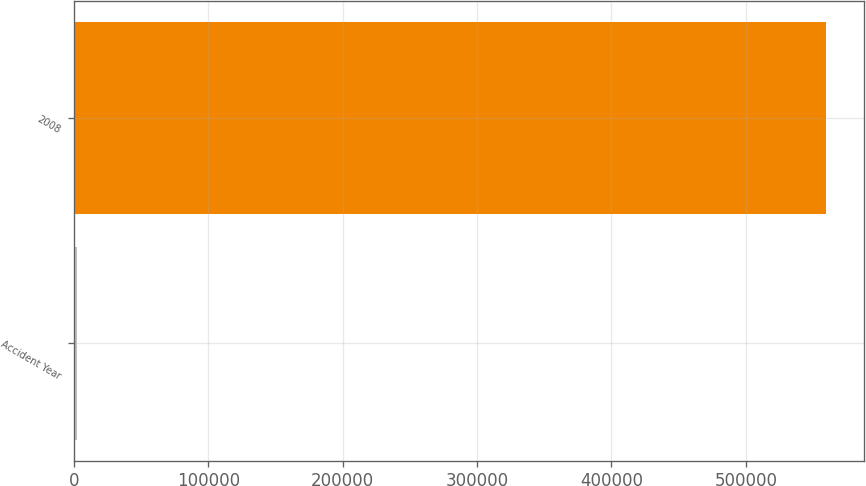Convert chart. <chart><loc_0><loc_0><loc_500><loc_500><bar_chart><fcel>Accident Year<fcel>2008<nl><fcel>2015<fcel>559727<nl></chart> 